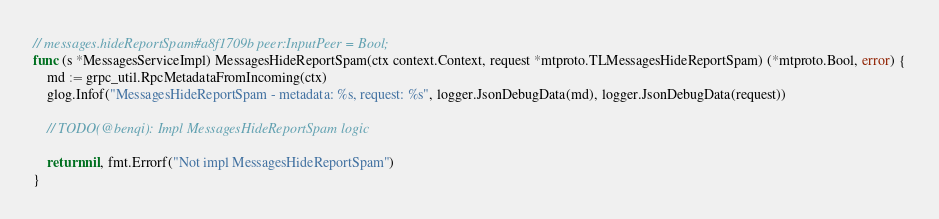Convert code to text. <code><loc_0><loc_0><loc_500><loc_500><_Go_>// messages.hideReportSpam#a8f1709b peer:InputPeer = Bool;
func (s *MessagesServiceImpl) MessagesHideReportSpam(ctx context.Context, request *mtproto.TLMessagesHideReportSpam) (*mtproto.Bool, error) {
    md := grpc_util.RpcMetadataFromIncoming(ctx)
    glog.Infof("MessagesHideReportSpam - metadata: %s, request: %s", logger.JsonDebugData(md), logger.JsonDebugData(request))

    // TODO(@benqi): Impl MessagesHideReportSpam logic

    return nil, fmt.Errorf("Not impl MessagesHideReportSpam")
}
</code> 